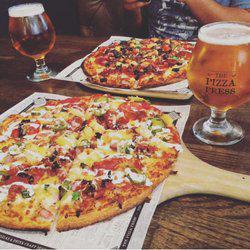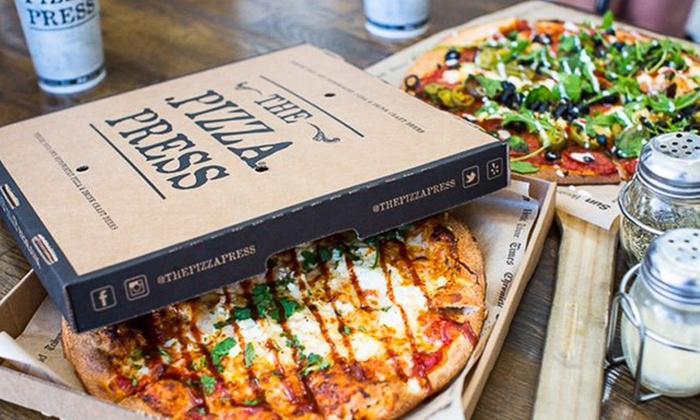The first image is the image on the left, the second image is the image on the right. For the images displayed, is the sentence "At least one of the drinks is in a paper cup." factually correct? Answer yes or no. Yes. The first image is the image on the left, the second image is the image on the right. Evaluate the accuracy of this statement regarding the images: "In the image on the right, the pizza is placed next to a salad.". Is it true? Answer yes or no. No. 